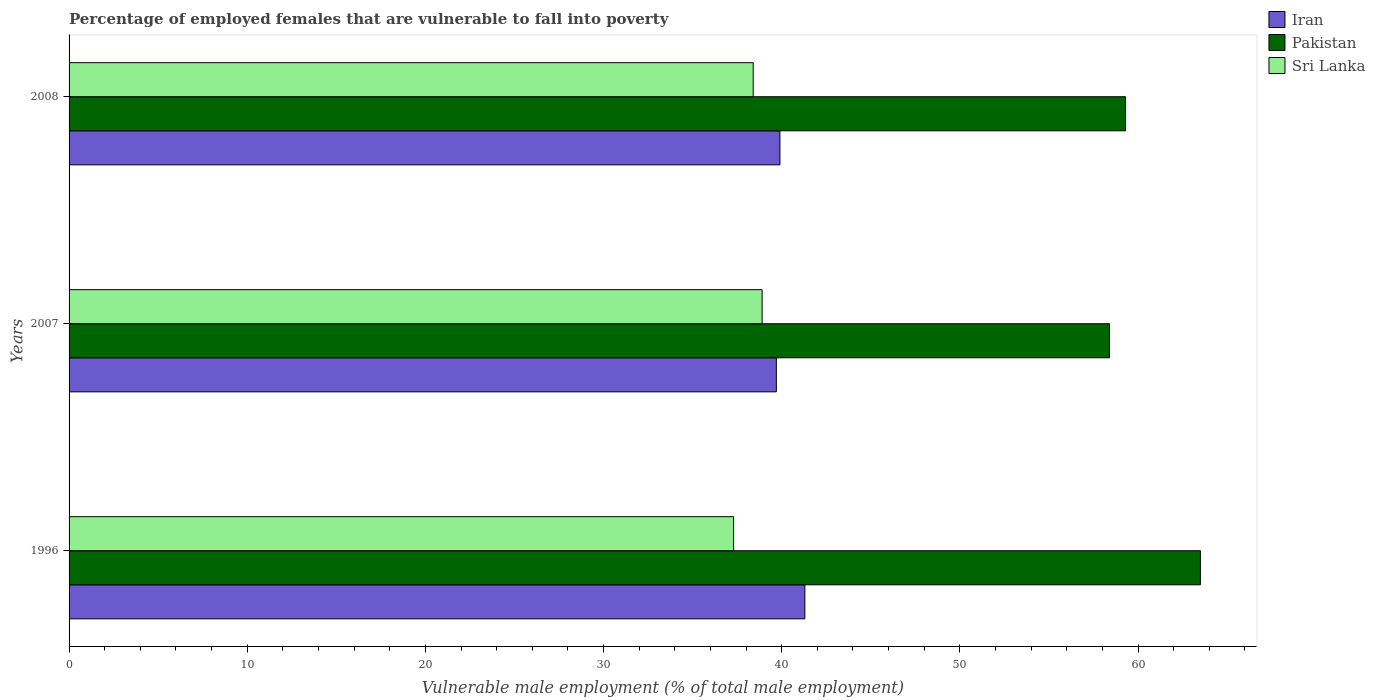How many different coloured bars are there?
Your response must be concise. 3. How many groups of bars are there?
Ensure brevity in your answer.  3. Are the number of bars on each tick of the Y-axis equal?
Your response must be concise. Yes. How many bars are there on the 3rd tick from the top?
Offer a terse response. 3. In how many cases, is the number of bars for a given year not equal to the number of legend labels?
Provide a succinct answer. 0. What is the percentage of employed females who are vulnerable to fall into poverty in Iran in 1996?
Provide a short and direct response. 41.3. Across all years, what is the maximum percentage of employed females who are vulnerable to fall into poverty in Iran?
Your answer should be very brief. 41.3. Across all years, what is the minimum percentage of employed females who are vulnerable to fall into poverty in Iran?
Your answer should be compact. 39.7. In which year was the percentage of employed females who are vulnerable to fall into poverty in Sri Lanka maximum?
Give a very brief answer. 2007. In which year was the percentage of employed females who are vulnerable to fall into poverty in Pakistan minimum?
Make the answer very short. 2007. What is the total percentage of employed females who are vulnerable to fall into poverty in Sri Lanka in the graph?
Offer a very short reply. 114.6. What is the difference between the percentage of employed females who are vulnerable to fall into poverty in Pakistan in 2007 and that in 2008?
Provide a succinct answer. -0.9. What is the difference between the percentage of employed females who are vulnerable to fall into poverty in Sri Lanka in 1996 and the percentage of employed females who are vulnerable to fall into poverty in Pakistan in 2008?
Your answer should be very brief. -22. What is the average percentage of employed females who are vulnerable to fall into poverty in Iran per year?
Provide a short and direct response. 40.3. In the year 2008, what is the difference between the percentage of employed females who are vulnerable to fall into poverty in Iran and percentage of employed females who are vulnerable to fall into poverty in Sri Lanka?
Offer a very short reply. 1.5. In how many years, is the percentage of employed females who are vulnerable to fall into poverty in Iran greater than 8 %?
Offer a very short reply. 3. What is the ratio of the percentage of employed females who are vulnerable to fall into poverty in Iran in 2007 to that in 2008?
Offer a very short reply. 0.99. Is the difference between the percentage of employed females who are vulnerable to fall into poverty in Iran in 1996 and 2007 greater than the difference between the percentage of employed females who are vulnerable to fall into poverty in Sri Lanka in 1996 and 2007?
Give a very brief answer. Yes. What is the difference between the highest and the second highest percentage of employed females who are vulnerable to fall into poverty in Sri Lanka?
Your answer should be very brief. 0.5. What is the difference between the highest and the lowest percentage of employed females who are vulnerable to fall into poverty in Iran?
Offer a terse response. 1.6. What does the 1st bar from the top in 2007 represents?
Your answer should be very brief. Sri Lanka. What does the 3rd bar from the bottom in 2007 represents?
Ensure brevity in your answer.  Sri Lanka. Is it the case that in every year, the sum of the percentage of employed females who are vulnerable to fall into poverty in Sri Lanka and percentage of employed females who are vulnerable to fall into poverty in Pakistan is greater than the percentage of employed females who are vulnerable to fall into poverty in Iran?
Your answer should be compact. Yes. How many years are there in the graph?
Make the answer very short. 3. Are the values on the major ticks of X-axis written in scientific E-notation?
Ensure brevity in your answer.  No. Does the graph contain any zero values?
Your answer should be very brief. No. Does the graph contain grids?
Ensure brevity in your answer.  No. Where does the legend appear in the graph?
Offer a very short reply. Top right. How many legend labels are there?
Offer a terse response. 3. How are the legend labels stacked?
Provide a succinct answer. Vertical. What is the title of the graph?
Offer a terse response. Percentage of employed females that are vulnerable to fall into poverty. What is the label or title of the X-axis?
Provide a succinct answer. Vulnerable male employment (% of total male employment). What is the label or title of the Y-axis?
Offer a terse response. Years. What is the Vulnerable male employment (% of total male employment) in Iran in 1996?
Ensure brevity in your answer.  41.3. What is the Vulnerable male employment (% of total male employment) of Pakistan in 1996?
Ensure brevity in your answer.  63.5. What is the Vulnerable male employment (% of total male employment) of Sri Lanka in 1996?
Your response must be concise. 37.3. What is the Vulnerable male employment (% of total male employment) in Iran in 2007?
Make the answer very short. 39.7. What is the Vulnerable male employment (% of total male employment) in Pakistan in 2007?
Offer a terse response. 58.4. What is the Vulnerable male employment (% of total male employment) in Sri Lanka in 2007?
Provide a short and direct response. 38.9. What is the Vulnerable male employment (% of total male employment) in Iran in 2008?
Your answer should be compact. 39.9. What is the Vulnerable male employment (% of total male employment) of Pakistan in 2008?
Keep it short and to the point. 59.3. What is the Vulnerable male employment (% of total male employment) in Sri Lanka in 2008?
Give a very brief answer. 38.4. Across all years, what is the maximum Vulnerable male employment (% of total male employment) of Iran?
Your answer should be very brief. 41.3. Across all years, what is the maximum Vulnerable male employment (% of total male employment) of Pakistan?
Make the answer very short. 63.5. Across all years, what is the maximum Vulnerable male employment (% of total male employment) of Sri Lanka?
Provide a succinct answer. 38.9. Across all years, what is the minimum Vulnerable male employment (% of total male employment) of Iran?
Offer a terse response. 39.7. Across all years, what is the minimum Vulnerable male employment (% of total male employment) in Pakistan?
Your answer should be very brief. 58.4. Across all years, what is the minimum Vulnerable male employment (% of total male employment) of Sri Lanka?
Your answer should be compact. 37.3. What is the total Vulnerable male employment (% of total male employment) in Iran in the graph?
Your answer should be very brief. 120.9. What is the total Vulnerable male employment (% of total male employment) of Pakistan in the graph?
Provide a short and direct response. 181.2. What is the total Vulnerable male employment (% of total male employment) in Sri Lanka in the graph?
Give a very brief answer. 114.6. What is the difference between the Vulnerable male employment (% of total male employment) of Iran in 1996 and that in 2007?
Keep it short and to the point. 1.6. What is the difference between the Vulnerable male employment (% of total male employment) of Pakistan in 1996 and that in 2007?
Keep it short and to the point. 5.1. What is the difference between the Vulnerable male employment (% of total male employment) in Sri Lanka in 1996 and that in 2007?
Keep it short and to the point. -1.6. What is the difference between the Vulnerable male employment (% of total male employment) of Iran in 1996 and that in 2008?
Offer a terse response. 1.4. What is the difference between the Vulnerable male employment (% of total male employment) in Pakistan in 2007 and that in 2008?
Offer a very short reply. -0.9. What is the difference between the Vulnerable male employment (% of total male employment) of Sri Lanka in 2007 and that in 2008?
Give a very brief answer. 0.5. What is the difference between the Vulnerable male employment (% of total male employment) of Iran in 1996 and the Vulnerable male employment (% of total male employment) of Pakistan in 2007?
Offer a terse response. -17.1. What is the difference between the Vulnerable male employment (% of total male employment) in Iran in 1996 and the Vulnerable male employment (% of total male employment) in Sri Lanka in 2007?
Ensure brevity in your answer.  2.4. What is the difference between the Vulnerable male employment (% of total male employment) in Pakistan in 1996 and the Vulnerable male employment (% of total male employment) in Sri Lanka in 2007?
Your response must be concise. 24.6. What is the difference between the Vulnerable male employment (% of total male employment) of Iran in 1996 and the Vulnerable male employment (% of total male employment) of Pakistan in 2008?
Give a very brief answer. -18. What is the difference between the Vulnerable male employment (% of total male employment) of Iran in 1996 and the Vulnerable male employment (% of total male employment) of Sri Lanka in 2008?
Your response must be concise. 2.9. What is the difference between the Vulnerable male employment (% of total male employment) in Pakistan in 1996 and the Vulnerable male employment (% of total male employment) in Sri Lanka in 2008?
Ensure brevity in your answer.  25.1. What is the difference between the Vulnerable male employment (% of total male employment) in Iran in 2007 and the Vulnerable male employment (% of total male employment) in Pakistan in 2008?
Provide a short and direct response. -19.6. What is the difference between the Vulnerable male employment (% of total male employment) in Pakistan in 2007 and the Vulnerable male employment (% of total male employment) in Sri Lanka in 2008?
Your answer should be compact. 20. What is the average Vulnerable male employment (% of total male employment) of Iran per year?
Provide a succinct answer. 40.3. What is the average Vulnerable male employment (% of total male employment) of Pakistan per year?
Offer a very short reply. 60.4. What is the average Vulnerable male employment (% of total male employment) in Sri Lanka per year?
Make the answer very short. 38.2. In the year 1996, what is the difference between the Vulnerable male employment (% of total male employment) of Iran and Vulnerable male employment (% of total male employment) of Pakistan?
Provide a short and direct response. -22.2. In the year 1996, what is the difference between the Vulnerable male employment (% of total male employment) in Pakistan and Vulnerable male employment (% of total male employment) in Sri Lanka?
Make the answer very short. 26.2. In the year 2007, what is the difference between the Vulnerable male employment (% of total male employment) of Iran and Vulnerable male employment (% of total male employment) of Pakistan?
Give a very brief answer. -18.7. In the year 2008, what is the difference between the Vulnerable male employment (% of total male employment) in Iran and Vulnerable male employment (% of total male employment) in Pakistan?
Ensure brevity in your answer.  -19.4. In the year 2008, what is the difference between the Vulnerable male employment (% of total male employment) of Pakistan and Vulnerable male employment (% of total male employment) of Sri Lanka?
Provide a succinct answer. 20.9. What is the ratio of the Vulnerable male employment (% of total male employment) of Iran in 1996 to that in 2007?
Your response must be concise. 1.04. What is the ratio of the Vulnerable male employment (% of total male employment) of Pakistan in 1996 to that in 2007?
Your answer should be compact. 1.09. What is the ratio of the Vulnerable male employment (% of total male employment) of Sri Lanka in 1996 to that in 2007?
Give a very brief answer. 0.96. What is the ratio of the Vulnerable male employment (% of total male employment) in Iran in 1996 to that in 2008?
Provide a short and direct response. 1.04. What is the ratio of the Vulnerable male employment (% of total male employment) in Pakistan in 1996 to that in 2008?
Give a very brief answer. 1.07. What is the ratio of the Vulnerable male employment (% of total male employment) in Sri Lanka in 1996 to that in 2008?
Keep it short and to the point. 0.97. What is the ratio of the Vulnerable male employment (% of total male employment) of Iran in 2007 to that in 2008?
Make the answer very short. 0.99. What is the ratio of the Vulnerable male employment (% of total male employment) of Pakistan in 2007 to that in 2008?
Offer a terse response. 0.98. What is the difference between the highest and the second highest Vulnerable male employment (% of total male employment) of Pakistan?
Keep it short and to the point. 4.2. What is the difference between the highest and the second highest Vulnerable male employment (% of total male employment) of Sri Lanka?
Offer a very short reply. 0.5. What is the difference between the highest and the lowest Vulnerable male employment (% of total male employment) of Iran?
Your answer should be compact. 1.6. 